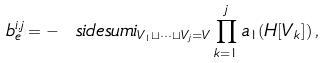<formula> <loc_0><loc_0><loc_500><loc_500>b _ { e } ^ { i , j } = - \ s i d e s u m { i } _ { V _ { 1 } \sqcup \dots \sqcup V _ { j } = V } \prod _ { k = 1 } ^ { j } a _ { 1 } ( H [ V _ { k } ] ) \, ,</formula> 